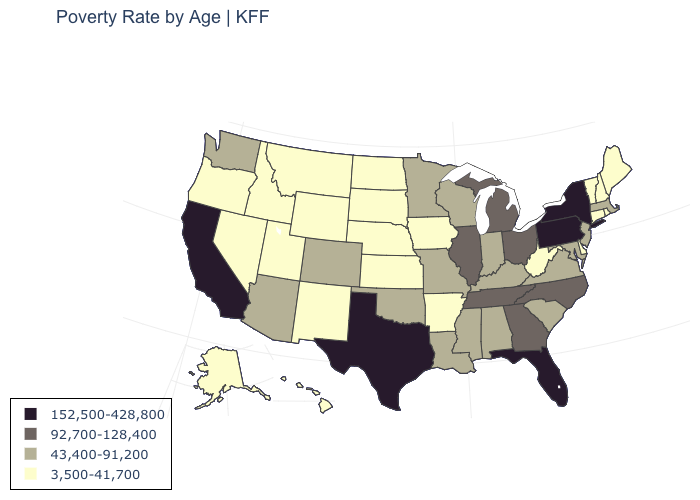Does West Virginia have the lowest value in the South?
Short answer required. Yes. What is the value of Arizona?
Quick response, please. 43,400-91,200. What is the value of Wyoming?
Quick response, please. 3,500-41,700. Which states have the lowest value in the USA?
Short answer required. Alaska, Arkansas, Connecticut, Delaware, Hawaii, Idaho, Iowa, Kansas, Maine, Montana, Nebraska, Nevada, New Hampshire, New Mexico, North Dakota, Oregon, Rhode Island, South Dakota, Utah, Vermont, West Virginia, Wyoming. What is the lowest value in states that border Florida?
Keep it brief. 43,400-91,200. Name the states that have a value in the range 43,400-91,200?
Answer briefly. Alabama, Arizona, Colorado, Indiana, Kentucky, Louisiana, Maryland, Massachusetts, Minnesota, Mississippi, Missouri, New Jersey, Oklahoma, South Carolina, Virginia, Washington, Wisconsin. Which states have the highest value in the USA?
Be succinct. California, Florida, New York, Pennsylvania, Texas. What is the value of Oregon?
Be succinct. 3,500-41,700. What is the value of Illinois?
Give a very brief answer. 92,700-128,400. Which states hav the highest value in the West?
Concise answer only. California. What is the value of Wisconsin?
Give a very brief answer. 43,400-91,200. What is the value of New York?
Concise answer only. 152,500-428,800. Does South Carolina have the lowest value in the South?
Concise answer only. No. Name the states that have a value in the range 92,700-128,400?
Answer briefly. Georgia, Illinois, Michigan, North Carolina, Ohio, Tennessee. Does Idaho have a higher value than Nevada?
Be succinct. No. 